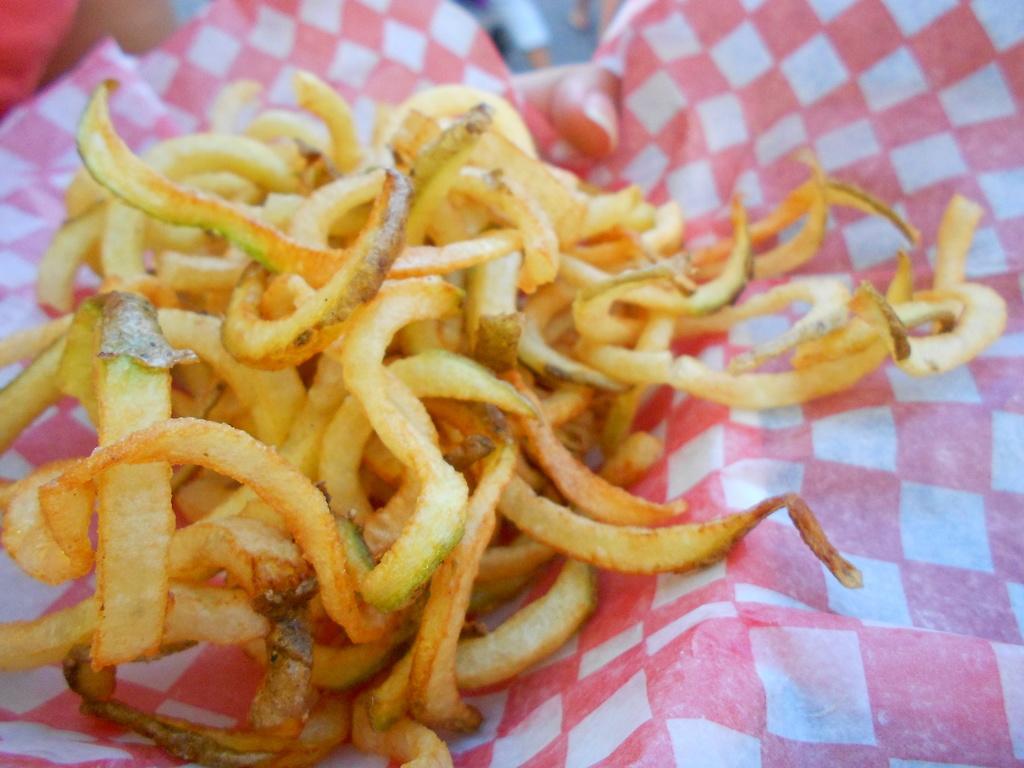Please provide a concise description of this image. In this image I can see food item on a oil paper. On the paper I can see a design of squares which are pink and white in color. 